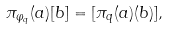Convert formula to latex. <formula><loc_0><loc_0><loc_500><loc_500>\pi _ { \varphi _ { q } } ( a ) [ b ] = [ \pi _ { q } ( a ) ( b ) ] ,</formula> 